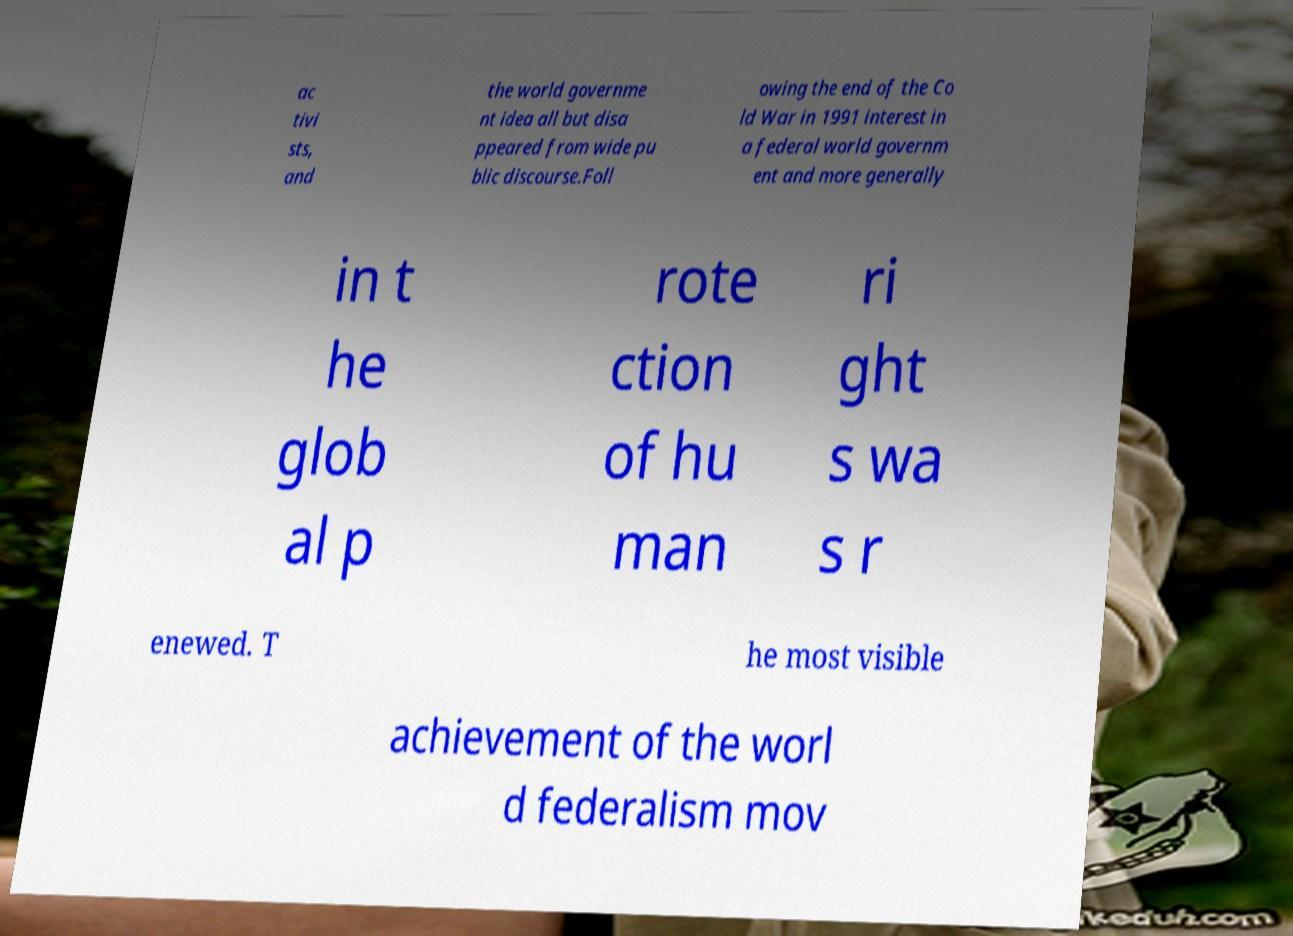Can you accurately transcribe the text from the provided image for me? ac tivi sts, and the world governme nt idea all but disa ppeared from wide pu blic discourse.Foll owing the end of the Co ld War in 1991 interest in a federal world governm ent and more generally in t he glob al p rote ction of hu man ri ght s wa s r enewed. T he most visible achievement of the worl d federalism mov 